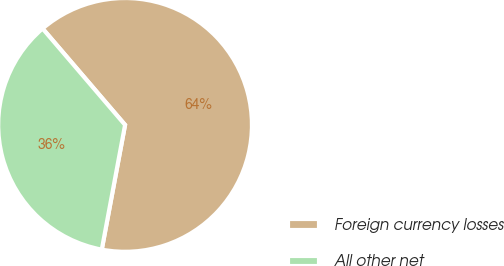Convert chart. <chart><loc_0><loc_0><loc_500><loc_500><pie_chart><fcel>Foreign currency losses<fcel>All other net<nl><fcel>64.21%<fcel>35.79%<nl></chart> 